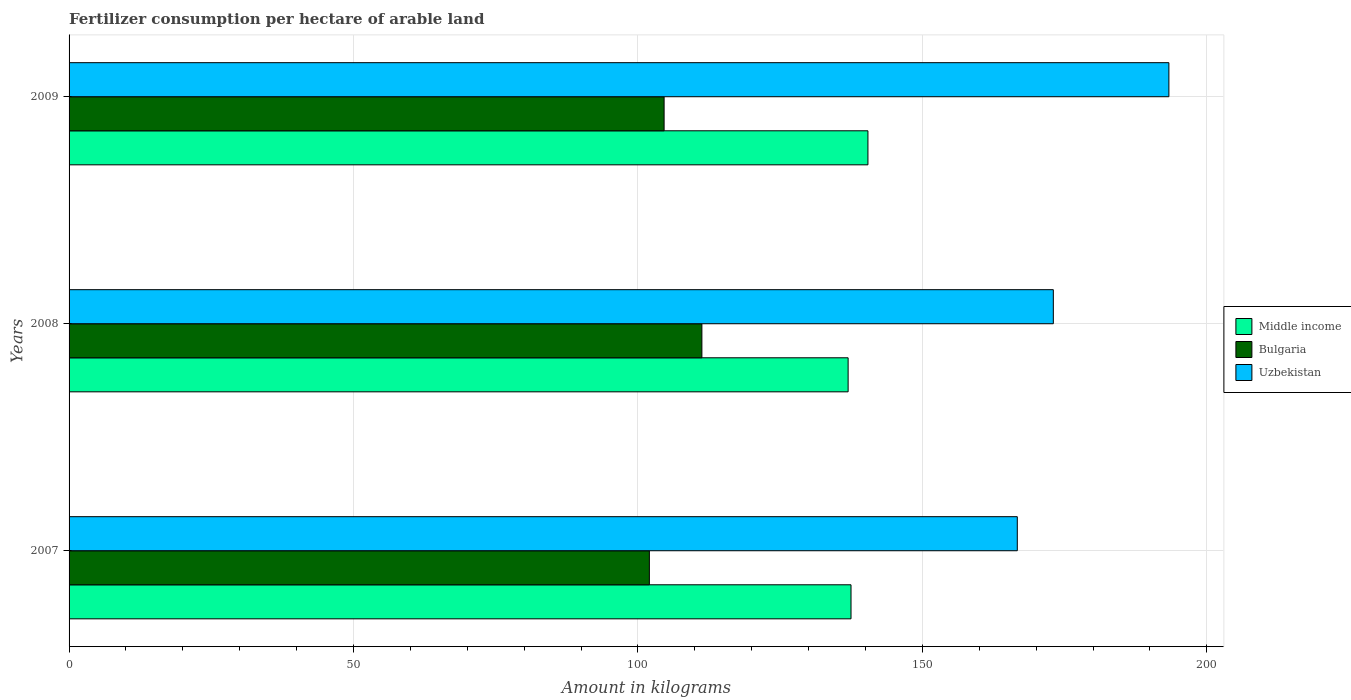How many different coloured bars are there?
Your response must be concise. 3. Are the number of bars on each tick of the Y-axis equal?
Ensure brevity in your answer.  Yes. How many bars are there on the 3rd tick from the top?
Keep it short and to the point. 3. What is the amount of fertilizer consumption in Bulgaria in 2009?
Keep it short and to the point. 104.6. Across all years, what is the maximum amount of fertilizer consumption in Middle income?
Ensure brevity in your answer.  140.43. Across all years, what is the minimum amount of fertilizer consumption in Bulgaria?
Your response must be concise. 102.01. In which year was the amount of fertilizer consumption in Uzbekistan minimum?
Keep it short and to the point. 2007. What is the total amount of fertilizer consumption in Middle income in the graph?
Offer a very short reply. 414.84. What is the difference between the amount of fertilizer consumption in Bulgaria in 2007 and that in 2009?
Give a very brief answer. -2.59. What is the difference between the amount of fertilizer consumption in Bulgaria in 2008 and the amount of fertilizer consumption in Middle income in 2007?
Keep it short and to the point. -26.21. What is the average amount of fertilizer consumption in Middle income per year?
Keep it short and to the point. 138.28. In the year 2009, what is the difference between the amount of fertilizer consumption in Middle income and amount of fertilizer consumption in Uzbekistan?
Keep it short and to the point. -52.9. In how many years, is the amount of fertilizer consumption in Middle income greater than 100 kg?
Your answer should be compact. 3. What is the ratio of the amount of fertilizer consumption in Middle income in 2007 to that in 2009?
Offer a very short reply. 0.98. Is the amount of fertilizer consumption in Middle income in 2007 less than that in 2008?
Your response must be concise. No. Is the difference between the amount of fertilizer consumption in Middle income in 2007 and 2008 greater than the difference between the amount of fertilizer consumption in Uzbekistan in 2007 and 2008?
Keep it short and to the point. Yes. What is the difference between the highest and the second highest amount of fertilizer consumption in Uzbekistan?
Keep it short and to the point. 20.32. What is the difference between the highest and the lowest amount of fertilizer consumption in Uzbekistan?
Keep it short and to the point. 26.65. In how many years, is the amount of fertilizer consumption in Bulgaria greater than the average amount of fertilizer consumption in Bulgaria taken over all years?
Your answer should be compact. 1. What does the 1st bar from the top in 2008 represents?
Offer a very short reply. Uzbekistan. What does the 2nd bar from the bottom in 2009 represents?
Your answer should be compact. Bulgaria. How many bars are there?
Make the answer very short. 9. Are all the bars in the graph horizontal?
Your response must be concise. Yes. Are the values on the major ticks of X-axis written in scientific E-notation?
Your response must be concise. No. Does the graph contain any zero values?
Your answer should be very brief. No. Does the graph contain grids?
Your answer should be very brief. Yes. Where does the legend appear in the graph?
Your answer should be very brief. Center right. How are the legend labels stacked?
Offer a terse response. Vertical. What is the title of the graph?
Provide a short and direct response. Fertilizer consumption per hectare of arable land. Does "Zambia" appear as one of the legend labels in the graph?
Ensure brevity in your answer.  No. What is the label or title of the X-axis?
Make the answer very short. Amount in kilograms. What is the Amount in kilograms of Middle income in 2007?
Offer a terse response. 137.46. What is the Amount in kilograms in Bulgaria in 2007?
Provide a succinct answer. 102.01. What is the Amount in kilograms in Uzbekistan in 2007?
Provide a short and direct response. 166.69. What is the Amount in kilograms in Middle income in 2008?
Provide a succinct answer. 136.95. What is the Amount in kilograms in Bulgaria in 2008?
Offer a very short reply. 111.24. What is the Amount in kilograms of Uzbekistan in 2008?
Your answer should be very brief. 173.02. What is the Amount in kilograms of Middle income in 2009?
Keep it short and to the point. 140.43. What is the Amount in kilograms of Bulgaria in 2009?
Your response must be concise. 104.6. What is the Amount in kilograms of Uzbekistan in 2009?
Offer a terse response. 193.34. Across all years, what is the maximum Amount in kilograms of Middle income?
Give a very brief answer. 140.43. Across all years, what is the maximum Amount in kilograms in Bulgaria?
Provide a short and direct response. 111.24. Across all years, what is the maximum Amount in kilograms of Uzbekistan?
Offer a very short reply. 193.34. Across all years, what is the minimum Amount in kilograms of Middle income?
Offer a terse response. 136.95. Across all years, what is the minimum Amount in kilograms in Bulgaria?
Provide a succinct answer. 102.01. Across all years, what is the minimum Amount in kilograms in Uzbekistan?
Provide a short and direct response. 166.69. What is the total Amount in kilograms in Middle income in the graph?
Provide a succinct answer. 414.84. What is the total Amount in kilograms in Bulgaria in the graph?
Your answer should be very brief. 317.85. What is the total Amount in kilograms of Uzbekistan in the graph?
Offer a very short reply. 533.04. What is the difference between the Amount in kilograms in Middle income in 2007 and that in 2008?
Ensure brevity in your answer.  0.51. What is the difference between the Amount in kilograms in Bulgaria in 2007 and that in 2008?
Keep it short and to the point. -9.23. What is the difference between the Amount in kilograms in Uzbekistan in 2007 and that in 2008?
Keep it short and to the point. -6.33. What is the difference between the Amount in kilograms of Middle income in 2007 and that in 2009?
Your response must be concise. -2.98. What is the difference between the Amount in kilograms of Bulgaria in 2007 and that in 2009?
Give a very brief answer. -2.59. What is the difference between the Amount in kilograms in Uzbekistan in 2007 and that in 2009?
Your answer should be very brief. -26.65. What is the difference between the Amount in kilograms in Middle income in 2008 and that in 2009?
Offer a very short reply. -3.48. What is the difference between the Amount in kilograms in Bulgaria in 2008 and that in 2009?
Give a very brief answer. 6.64. What is the difference between the Amount in kilograms of Uzbekistan in 2008 and that in 2009?
Make the answer very short. -20.32. What is the difference between the Amount in kilograms in Middle income in 2007 and the Amount in kilograms in Bulgaria in 2008?
Your answer should be compact. 26.21. What is the difference between the Amount in kilograms in Middle income in 2007 and the Amount in kilograms in Uzbekistan in 2008?
Your answer should be compact. -35.56. What is the difference between the Amount in kilograms of Bulgaria in 2007 and the Amount in kilograms of Uzbekistan in 2008?
Make the answer very short. -71.01. What is the difference between the Amount in kilograms in Middle income in 2007 and the Amount in kilograms in Bulgaria in 2009?
Provide a short and direct response. 32.86. What is the difference between the Amount in kilograms in Middle income in 2007 and the Amount in kilograms in Uzbekistan in 2009?
Provide a succinct answer. -55.88. What is the difference between the Amount in kilograms of Bulgaria in 2007 and the Amount in kilograms of Uzbekistan in 2009?
Keep it short and to the point. -91.33. What is the difference between the Amount in kilograms in Middle income in 2008 and the Amount in kilograms in Bulgaria in 2009?
Provide a succinct answer. 32.35. What is the difference between the Amount in kilograms of Middle income in 2008 and the Amount in kilograms of Uzbekistan in 2009?
Make the answer very short. -56.39. What is the difference between the Amount in kilograms in Bulgaria in 2008 and the Amount in kilograms in Uzbekistan in 2009?
Keep it short and to the point. -82.09. What is the average Amount in kilograms of Middle income per year?
Make the answer very short. 138.28. What is the average Amount in kilograms in Bulgaria per year?
Make the answer very short. 105.95. What is the average Amount in kilograms of Uzbekistan per year?
Offer a terse response. 177.68. In the year 2007, what is the difference between the Amount in kilograms in Middle income and Amount in kilograms in Bulgaria?
Give a very brief answer. 35.45. In the year 2007, what is the difference between the Amount in kilograms in Middle income and Amount in kilograms in Uzbekistan?
Provide a succinct answer. -29.23. In the year 2007, what is the difference between the Amount in kilograms of Bulgaria and Amount in kilograms of Uzbekistan?
Keep it short and to the point. -64.68. In the year 2008, what is the difference between the Amount in kilograms of Middle income and Amount in kilograms of Bulgaria?
Make the answer very short. 25.71. In the year 2008, what is the difference between the Amount in kilograms in Middle income and Amount in kilograms in Uzbekistan?
Offer a terse response. -36.07. In the year 2008, what is the difference between the Amount in kilograms in Bulgaria and Amount in kilograms in Uzbekistan?
Your response must be concise. -61.78. In the year 2009, what is the difference between the Amount in kilograms of Middle income and Amount in kilograms of Bulgaria?
Provide a short and direct response. 35.83. In the year 2009, what is the difference between the Amount in kilograms of Middle income and Amount in kilograms of Uzbekistan?
Provide a short and direct response. -52.9. In the year 2009, what is the difference between the Amount in kilograms of Bulgaria and Amount in kilograms of Uzbekistan?
Provide a succinct answer. -88.74. What is the ratio of the Amount in kilograms in Bulgaria in 2007 to that in 2008?
Make the answer very short. 0.92. What is the ratio of the Amount in kilograms of Uzbekistan in 2007 to that in 2008?
Your response must be concise. 0.96. What is the ratio of the Amount in kilograms in Middle income in 2007 to that in 2009?
Provide a succinct answer. 0.98. What is the ratio of the Amount in kilograms of Bulgaria in 2007 to that in 2009?
Keep it short and to the point. 0.98. What is the ratio of the Amount in kilograms in Uzbekistan in 2007 to that in 2009?
Your response must be concise. 0.86. What is the ratio of the Amount in kilograms in Middle income in 2008 to that in 2009?
Give a very brief answer. 0.98. What is the ratio of the Amount in kilograms of Bulgaria in 2008 to that in 2009?
Your answer should be very brief. 1.06. What is the ratio of the Amount in kilograms in Uzbekistan in 2008 to that in 2009?
Give a very brief answer. 0.89. What is the difference between the highest and the second highest Amount in kilograms in Middle income?
Offer a very short reply. 2.98. What is the difference between the highest and the second highest Amount in kilograms in Bulgaria?
Your response must be concise. 6.64. What is the difference between the highest and the second highest Amount in kilograms of Uzbekistan?
Your response must be concise. 20.32. What is the difference between the highest and the lowest Amount in kilograms of Middle income?
Your answer should be compact. 3.48. What is the difference between the highest and the lowest Amount in kilograms in Bulgaria?
Give a very brief answer. 9.23. What is the difference between the highest and the lowest Amount in kilograms in Uzbekistan?
Your answer should be very brief. 26.65. 